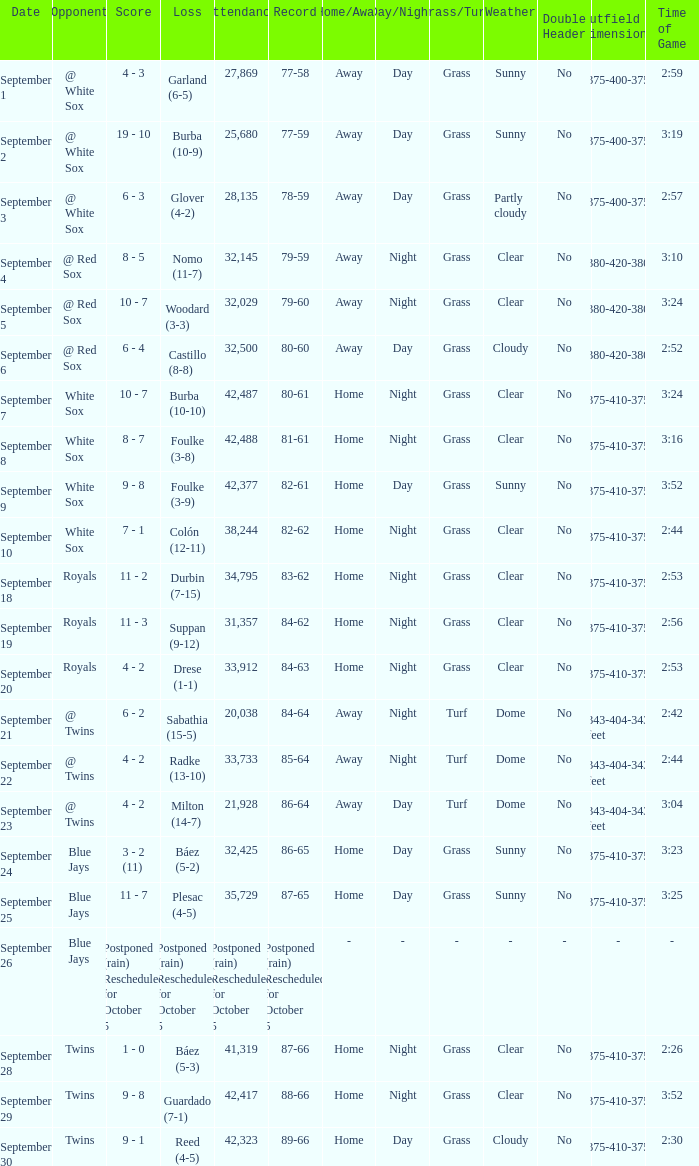What is the record of the game with 28,135 people in attendance? 78-59. 